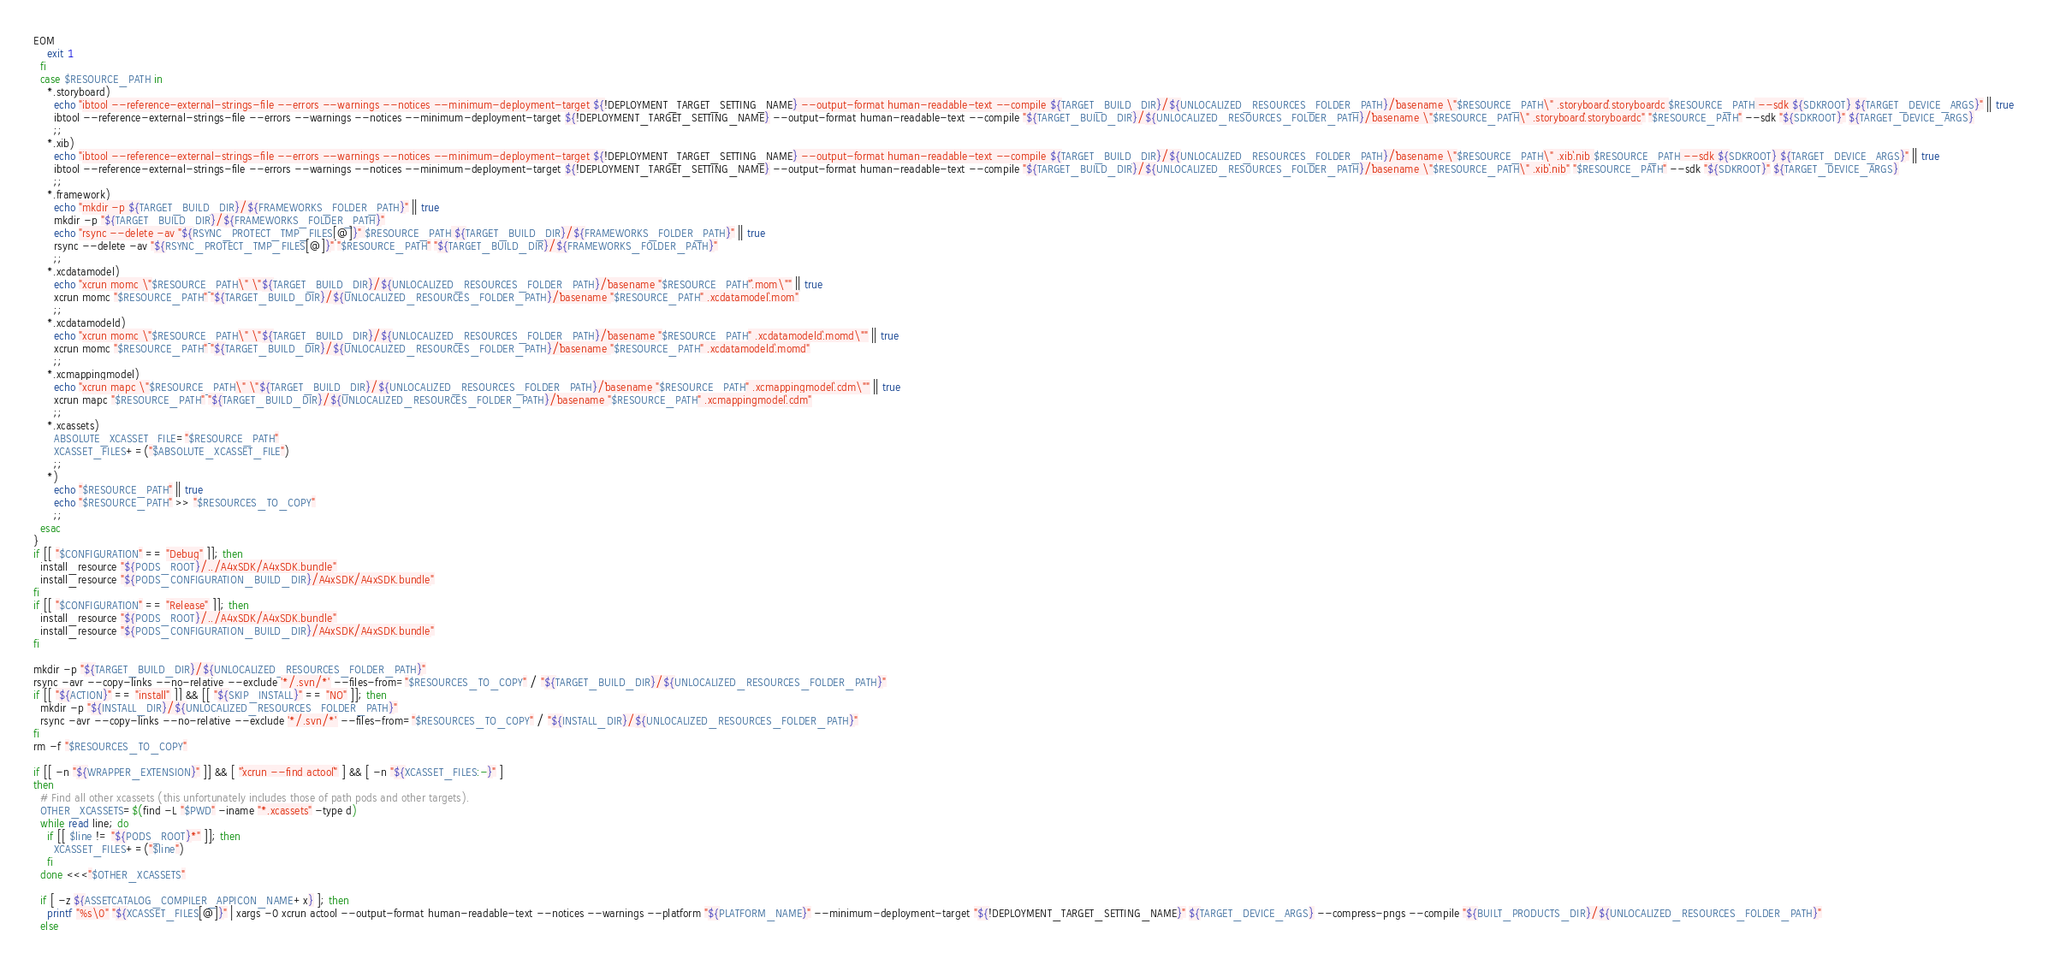Convert code to text. <code><loc_0><loc_0><loc_500><loc_500><_Bash_>EOM
    exit 1
  fi
  case $RESOURCE_PATH in
    *.storyboard)
      echo "ibtool --reference-external-strings-file --errors --warnings --notices --minimum-deployment-target ${!DEPLOYMENT_TARGET_SETTING_NAME} --output-format human-readable-text --compile ${TARGET_BUILD_DIR}/${UNLOCALIZED_RESOURCES_FOLDER_PATH}/`basename \"$RESOURCE_PATH\" .storyboard`.storyboardc $RESOURCE_PATH --sdk ${SDKROOT} ${TARGET_DEVICE_ARGS}" || true
      ibtool --reference-external-strings-file --errors --warnings --notices --minimum-deployment-target ${!DEPLOYMENT_TARGET_SETTING_NAME} --output-format human-readable-text --compile "${TARGET_BUILD_DIR}/${UNLOCALIZED_RESOURCES_FOLDER_PATH}/`basename \"$RESOURCE_PATH\" .storyboard`.storyboardc" "$RESOURCE_PATH" --sdk "${SDKROOT}" ${TARGET_DEVICE_ARGS}
      ;;
    *.xib)
      echo "ibtool --reference-external-strings-file --errors --warnings --notices --minimum-deployment-target ${!DEPLOYMENT_TARGET_SETTING_NAME} --output-format human-readable-text --compile ${TARGET_BUILD_DIR}/${UNLOCALIZED_RESOURCES_FOLDER_PATH}/`basename \"$RESOURCE_PATH\" .xib`.nib $RESOURCE_PATH --sdk ${SDKROOT} ${TARGET_DEVICE_ARGS}" || true
      ibtool --reference-external-strings-file --errors --warnings --notices --minimum-deployment-target ${!DEPLOYMENT_TARGET_SETTING_NAME} --output-format human-readable-text --compile "${TARGET_BUILD_DIR}/${UNLOCALIZED_RESOURCES_FOLDER_PATH}/`basename \"$RESOURCE_PATH\" .xib`.nib" "$RESOURCE_PATH" --sdk "${SDKROOT}" ${TARGET_DEVICE_ARGS}
      ;;
    *.framework)
      echo "mkdir -p ${TARGET_BUILD_DIR}/${FRAMEWORKS_FOLDER_PATH}" || true
      mkdir -p "${TARGET_BUILD_DIR}/${FRAMEWORKS_FOLDER_PATH}"
      echo "rsync --delete -av "${RSYNC_PROTECT_TMP_FILES[@]}" $RESOURCE_PATH ${TARGET_BUILD_DIR}/${FRAMEWORKS_FOLDER_PATH}" || true
      rsync --delete -av "${RSYNC_PROTECT_TMP_FILES[@]}" "$RESOURCE_PATH" "${TARGET_BUILD_DIR}/${FRAMEWORKS_FOLDER_PATH}"
      ;;
    *.xcdatamodel)
      echo "xcrun momc \"$RESOURCE_PATH\" \"${TARGET_BUILD_DIR}/${UNLOCALIZED_RESOURCES_FOLDER_PATH}/`basename "$RESOURCE_PATH"`.mom\"" || true
      xcrun momc "$RESOURCE_PATH" "${TARGET_BUILD_DIR}/${UNLOCALIZED_RESOURCES_FOLDER_PATH}/`basename "$RESOURCE_PATH" .xcdatamodel`.mom"
      ;;
    *.xcdatamodeld)
      echo "xcrun momc \"$RESOURCE_PATH\" \"${TARGET_BUILD_DIR}/${UNLOCALIZED_RESOURCES_FOLDER_PATH}/`basename "$RESOURCE_PATH" .xcdatamodeld`.momd\"" || true
      xcrun momc "$RESOURCE_PATH" "${TARGET_BUILD_DIR}/${UNLOCALIZED_RESOURCES_FOLDER_PATH}/`basename "$RESOURCE_PATH" .xcdatamodeld`.momd"
      ;;
    *.xcmappingmodel)
      echo "xcrun mapc \"$RESOURCE_PATH\" \"${TARGET_BUILD_DIR}/${UNLOCALIZED_RESOURCES_FOLDER_PATH}/`basename "$RESOURCE_PATH" .xcmappingmodel`.cdm\"" || true
      xcrun mapc "$RESOURCE_PATH" "${TARGET_BUILD_DIR}/${UNLOCALIZED_RESOURCES_FOLDER_PATH}/`basename "$RESOURCE_PATH" .xcmappingmodel`.cdm"
      ;;
    *.xcassets)
      ABSOLUTE_XCASSET_FILE="$RESOURCE_PATH"
      XCASSET_FILES+=("$ABSOLUTE_XCASSET_FILE")
      ;;
    *)
      echo "$RESOURCE_PATH" || true
      echo "$RESOURCE_PATH" >> "$RESOURCES_TO_COPY"
      ;;
  esac
}
if [[ "$CONFIGURATION" == "Debug" ]]; then
  install_resource "${PODS_ROOT}/../A4xSDK/A4xSDK.bundle"
  install_resource "${PODS_CONFIGURATION_BUILD_DIR}/A4xSDK/A4xSDK.bundle"
fi
if [[ "$CONFIGURATION" == "Release" ]]; then
  install_resource "${PODS_ROOT}/../A4xSDK/A4xSDK.bundle"
  install_resource "${PODS_CONFIGURATION_BUILD_DIR}/A4xSDK/A4xSDK.bundle"
fi

mkdir -p "${TARGET_BUILD_DIR}/${UNLOCALIZED_RESOURCES_FOLDER_PATH}"
rsync -avr --copy-links --no-relative --exclude '*/.svn/*' --files-from="$RESOURCES_TO_COPY" / "${TARGET_BUILD_DIR}/${UNLOCALIZED_RESOURCES_FOLDER_PATH}"
if [[ "${ACTION}" == "install" ]] && [[ "${SKIP_INSTALL}" == "NO" ]]; then
  mkdir -p "${INSTALL_DIR}/${UNLOCALIZED_RESOURCES_FOLDER_PATH}"
  rsync -avr --copy-links --no-relative --exclude '*/.svn/*' --files-from="$RESOURCES_TO_COPY" / "${INSTALL_DIR}/${UNLOCALIZED_RESOURCES_FOLDER_PATH}"
fi
rm -f "$RESOURCES_TO_COPY"

if [[ -n "${WRAPPER_EXTENSION}" ]] && [ "`xcrun --find actool`" ] && [ -n "${XCASSET_FILES:-}" ]
then
  # Find all other xcassets (this unfortunately includes those of path pods and other targets).
  OTHER_XCASSETS=$(find -L "$PWD" -iname "*.xcassets" -type d)
  while read line; do
    if [[ $line != "${PODS_ROOT}*" ]]; then
      XCASSET_FILES+=("$line")
    fi
  done <<<"$OTHER_XCASSETS"

  if [ -z ${ASSETCATALOG_COMPILER_APPICON_NAME+x} ]; then
    printf "%s\0" "${XCASSET_FILES[@]}" | xargs -0 xcrun actool --output-format human-readable-text --notices --warnings --platform "${PLATFORM_NAME}" --minimum-deployment-target "${!DEPLOYMENT_TARGET_SETTING_NAME}" ${TARGET_DEVICE_ARGS} --compress-pngs --compile "${BUILT_PRODUCTS_DIR}/${UNLOCALIZED_RESOURCES_FOLDER_PATH}"
  else</code> 